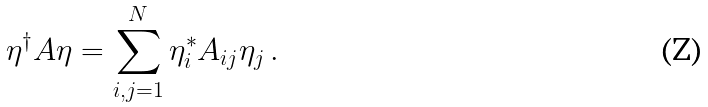Convert formula to latex. <formula><loc_0><loc_0><loc_500><loc_500>\eta ^ { \dagger } A \eta = \sum _ { i , j = 1 } ^ { N } \eta ^ { * } _ { i } A _ { i j } \eta _ { j } \, .</formula> 